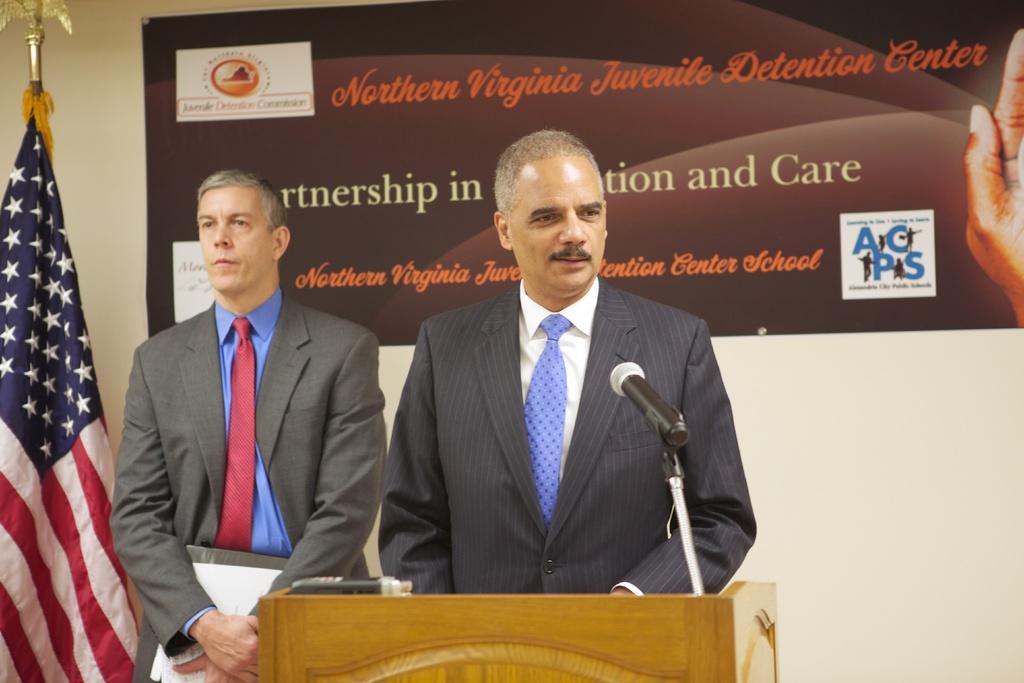Can you describe this image briefly? In this picture I can see couple of them standing and I can see a man standing at a podium and speaking with the help of a microphone and I can see a flag on the left side and I can see another man holding papers and a file in his hand. 